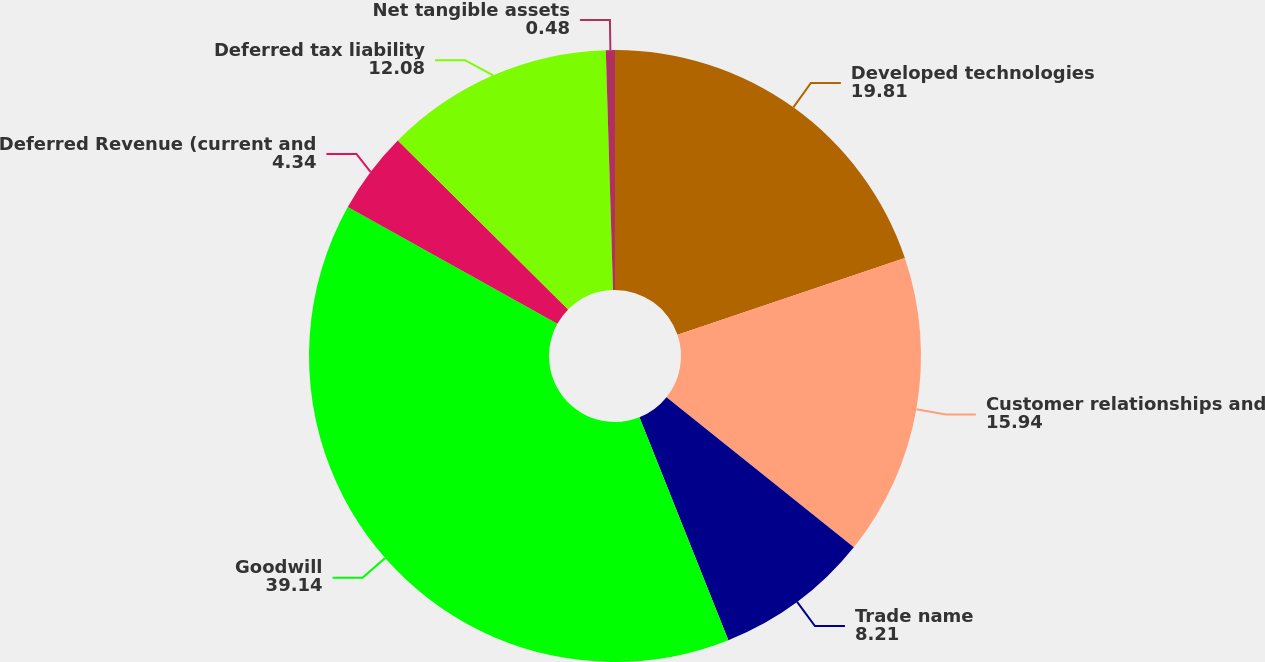Convert chart. <chart><loc_0><loc_0><loc_500><loc_500><pie_chart><fcel>Developed technologies<fcel>Customer relationships and<fcel>Trade name<fcel>Goodwill<fcel>Deferred Revenue (current and<fcel>Deferred tax liability<fcel>Net tangible assets<nl><fcel>19.81%<fcel>15.94%<fcel>8.21%<fcel>39.14%<fcel>4.34%<fcel>12.08%<fcel>0.48%<nl></chart> 